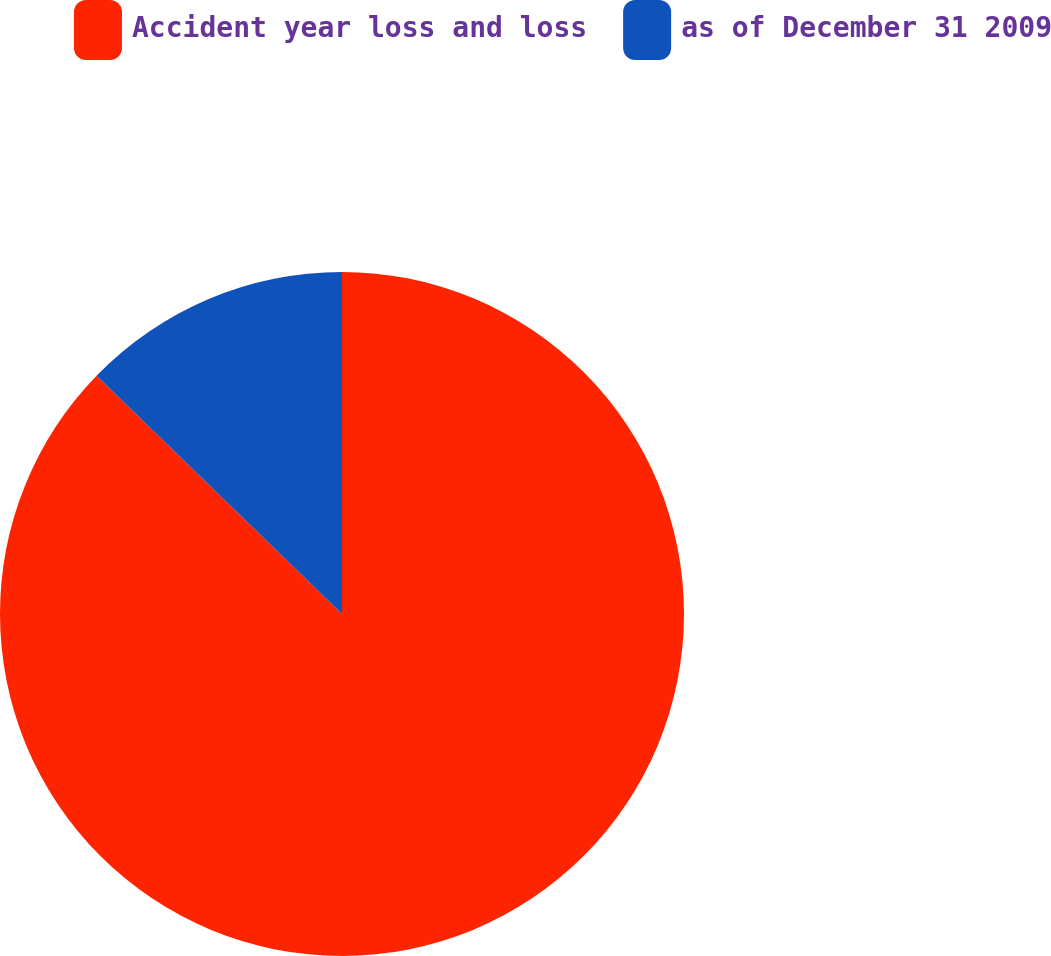Convert chart. <chart><loc_0><loc_0><loc_500><loc_500><pie_chart><fcel>Accident year loss and loss<fcel>as of December 31 2009<nl><fcel>87.26%<fcel>12.74%<nl></chart> 